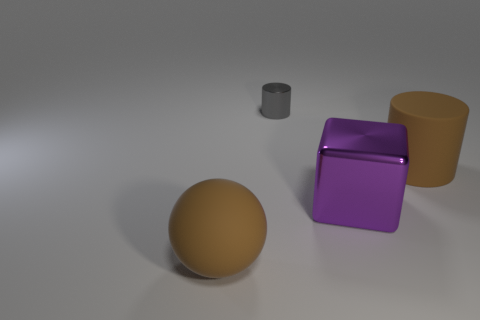Add 4 rubber blocks. How many objects exist? 8 Subtract 0 gray blocks. How many objects are left? 4 Subtract all tiny things. Subtract all big blue objects. How many objects are left? 3 Add 4 big brown matte cylinders. How many big brown matte cylinders are left? 5 Add 3 blocks. How many blocks exist? 4 